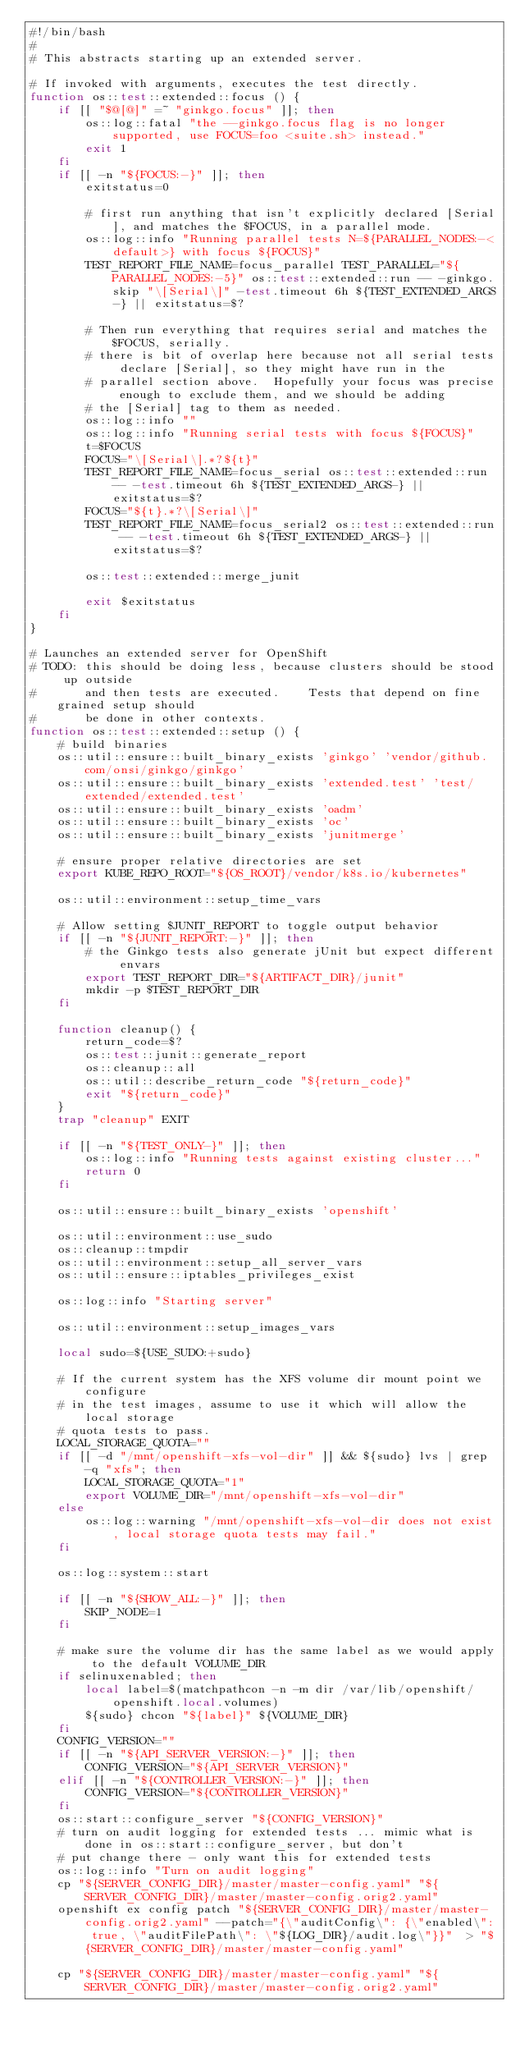<code> <loc_0><loc_0><loc_500><loc_500><_Bash_>#!/bin/bash
#
# This abstracts starting up an extended server.

# If invoked with arguments, executes the test directly.
function os::test::extended::focus () {
	if [[ "$@[@]" =~ "ginkgo.focus" ]]; then
		os::log::fatal "the --ginkgo.focus flag is no longer supported, use FOCUS=foo <suite.sh> instead."
		exit 1
	fi
	if [[ -n "${FOCUS:-}" ]]; then
		exitstatus=0

		# first run anything that isn't explicitly declared [Serial], and matches the $FOCUS, in a parallel mode.
		os::log::info "Running parallel tests N=${PARALLEL_NODES:-<default>} with focus ${FOCUS}"
		TEST_REPORT_FILE_NAME=focus_parallel TEST_PARALLEL="${PARALLEL_NODES:-5}" os::test::extended::run -- -ginkgo.skip "\[Serial\]" -test.timeout 6h ${TEST_EXTENDED_ARGS-} || exitstatus=$?

		# Then run everything that requires serial and matches the $FOCUS, serially.
		# there is bit of overlap here because not all serial tests declare [Serial], so they might have run in the
		# parallel section above.  Hopefully your focus was precise enough to exclude them, and we should be adding
		# the [Serial] tag to them as needed.
		os::log::info ""
		os::log::info "Running serial tests with focus ${FOCUS}"
		t=$FOCUS
		FOCUS="\[Serial\].*?${t}"
		TEST_REPORT_FILE_NAME=focus_serial os::test::extended::run -- -test.timeout 6h ${TEST_EXTENDED_ARGS-} || exitstatus=$?
		FOCUS="${t}.*?\[Serial\]"
		TEST_REPORT_FILE_NAME=focus_serial2 os::test::extended::run -- -test.timeout 6h ${TEST_EXTENDED_ARGS-} || exitstatus=$?

		os::test::extended::merge_junit

		exit $exitstatus
	fi
}

# Launches an extended server for OpenShift
# TODO: this should be doing less, because clusters should be stood up outside
#		and then tests are executed.	Tests that depend on fine grained setup should
#		be done in other contexts.
function os::test::extended::setup () {
	# build binaries
	os::util::ensure::built_binary_exists 'ginkgo' 'vendor/github.com/onsi/ginkgo/ginkgo'
	os::util::ensure::built_binary_exists 'extended.test' 'test/extended/extended.test'
	os::util::ensure::built_binary_exists 'oadm'
	os::util::ensure::built_binary_exists 'oc'
	os::util::ensure::built_binary_exists 'junitmerge'

	# ensure proper relative directories are set
	export KUBE_REPO_ROOT="${OS_ROOT}/vendor/k8s.io/kubernetes"

	os::util::environment::setup_time_vars

	# Allow setting $JUNIT_REPORT to toggle output behavior
	if [[ -n "${JUNIT_REPORT:-}" ]]; then
		# the Ginkgo tests also generate jUnit but expect different envars
		export TEST_REPORT_DIR="${ARTIFACT_DIR}/junit"
		mkdir -p $TEST_REPORT_DIR
	fi

	function cleanup() {
		return_code=$?
		os::test::junit::generate_report
		os::cleanup::all
		os::util::describe_return_code "${return_code}"
		exit "${return_code}"
	}
	trap "cleanup" EXIT

	if [[ -n "${TEST_ONLY-}" ]]; then
		os::log::info "Running tests against existing cluster..."
		return 0
	fi

	os::util::ensure::built_binary_exists 'openshift'

	os::util::environment::use_sudo
	os::cleanup::tmpdir
	os::util::environment::setup_all_server_vars
	os::util::ensure::iptables_privileges_exist

	os::log::info "Starting server"

	os::util::environment::setup_images_vars

	local sudo=${USE_SUDO:+sudo}

	# If the current system has the XFS volume dir mount point we configure
	# in the test images, assume to use it which will allow the local storage
	# quota tests to pass.
	LOCAL_STORAGE_QUOTA=""
	if [[ -d "/mnt/openshift-xfs-vol-dir" ]] && ${sudo} lvs | grep -q "xfs"; then
		LOCAL_STORAGE_QUOTA="1"
		export VOLUME_DIR="/mnt/openshift-xfs-vol-dir"
	else
		os::log::warning "/mnt/openshift-xfs-vol-dir does not exist, local storage quota tests may fail."
	fi

	os::log::system::start

	if [[ -n "${SHOW_ALL:-}" ]]; then
		SKIP_NODE=1
	fi

	# make sure the volume dir has the same label as we would apply to the default VOLUME_DIR
	if selinuxenabled; then
		local label=$(matchpathcon -n -m dir /var/lib/openshift/openshift.local.volumes)
		${sudo} chcon "${label}" ${VOLUME_DIR}
	fi
	CONFIG_VERSION=""
	if [[ -n "${API_SERVER_VERSION:-}" ]]; then
		CONFIG_VERSION="${API_SERVER_VERSION}"
	elif [[ -n "${CONTROLLER_VERSION:-}" ]]; then
		CONFIG_VERSION="${CONTROLLER_VERSION}"
	fi
	os::start::configure_server "${CONFIG_VERSION}"
	# turn on audit logging for extended tests ... mimic what is done in os::start::configure_server, but don't
	# put change there - only want this for extended tests
	os::log::info "Turn on audit logging"
	cp "${SERVER_CONFIG_DIR}/master/master-config.yaml" "${SERVER_CONFIG_DIR}/master/master-config.orig2.yaml"
	openshift ex config patch "${SERVER_CONFIG_DIR}/master/master-config.orig2.yaml" --patch="{\"auditConfig\": {\"enabled\": true, \"auditFilePath\": \"${LOG_DIR}/audit.log\"}}"  > "${SERVER_CONFIG_DIR}/master/master-config.yaml"

	cp "${SERVER_CONFIG_DIR}/master/master-config.yaml" "${SERVER_CONFIG_DIR}/master/master-config.orig2.yaml"</code> 